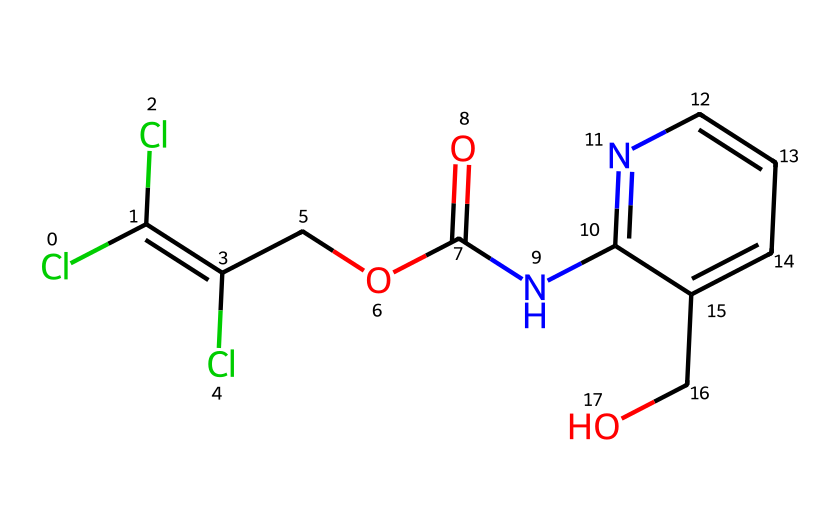What is the main functional group present in triclopyr? The main functional group in triclopyr is an amide (indicated by the -CO-N- linkage in the structure).
Answer: amide How many chlorine atoms are present in triclopyr? By observing the structure, there are three chlorine (Cl) atoms directly attached to the carbon atoms in the chemical.
Answer: three What type of chemical is triclopyr classified as? Triclopyr is classified as a herbicide, designed to control woody plants and weeds.
Answer: herbicide What is the total number of carbon atoms in the structure? Counting the carbon atoms in the structure shows there are 10 carbon (C) atoms present in triclopyr.
Answer: ten Which element in triclopyr contributes to its lipid solubility? The presence of the benzene ring (aromatic structure) enhances lipid solubility due to its hydrophobic characteristics.
Answer: benzene ring What is the approximate molecular weight of triclopyr? Using the molecular weights of each atom from the chemical structure, the approximate total adds up to about 221 grams per mole.
Answer: 221 